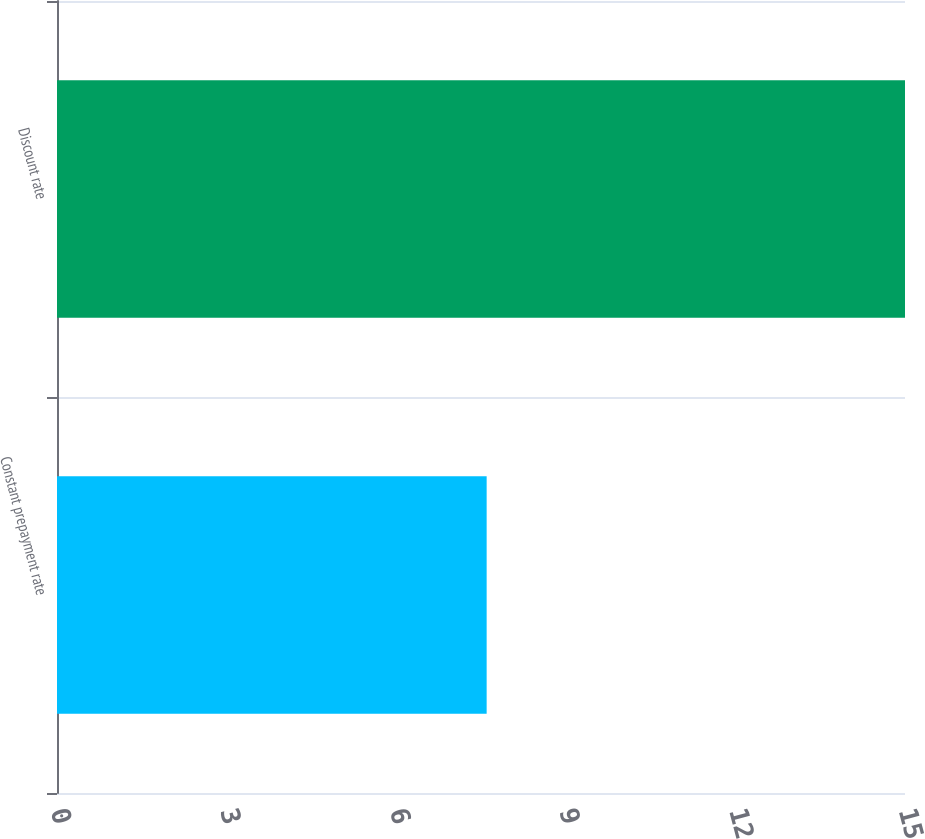<chart> <loc_0><loc_0><loc_500><loc_500><bar_chart><fcel>Constant prepayment rate<fcel>Discount rate<nl><fcel>7.6<fcel>15<nl></chart> 